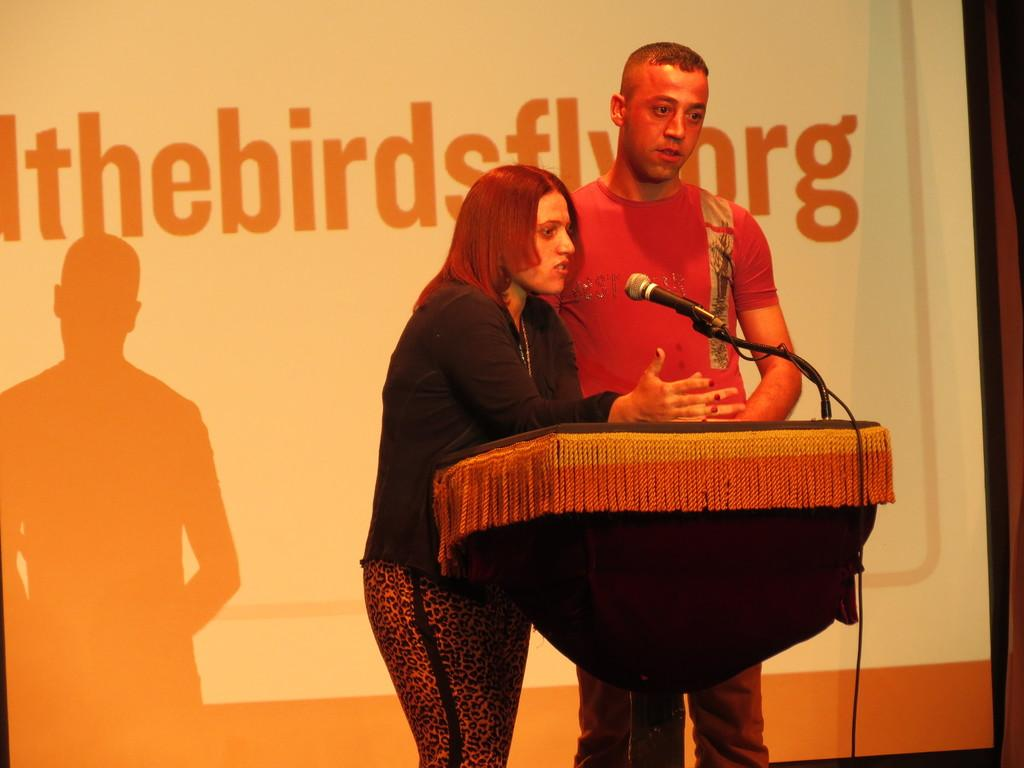What is happening in the image involving the people and the podium? There are people standing near a podium in the image. What equipment is present for the people to use for speaking? There is a microphone with a stand in front of the people. What can be seen hanging or displayed behind the people and the podium? There is a banner visible behind the people and the podium. Can you tell me how many rings are on the microphone stand in the image? There is no mention of rings on the microphone stand in the image; it only has a microphone attached to it. What type of control is being used to adjust the height of the banner in the image? There is no indication of any control for adjusting the banner in the image; it is simply hanging or displayed behind the people and the podium. 